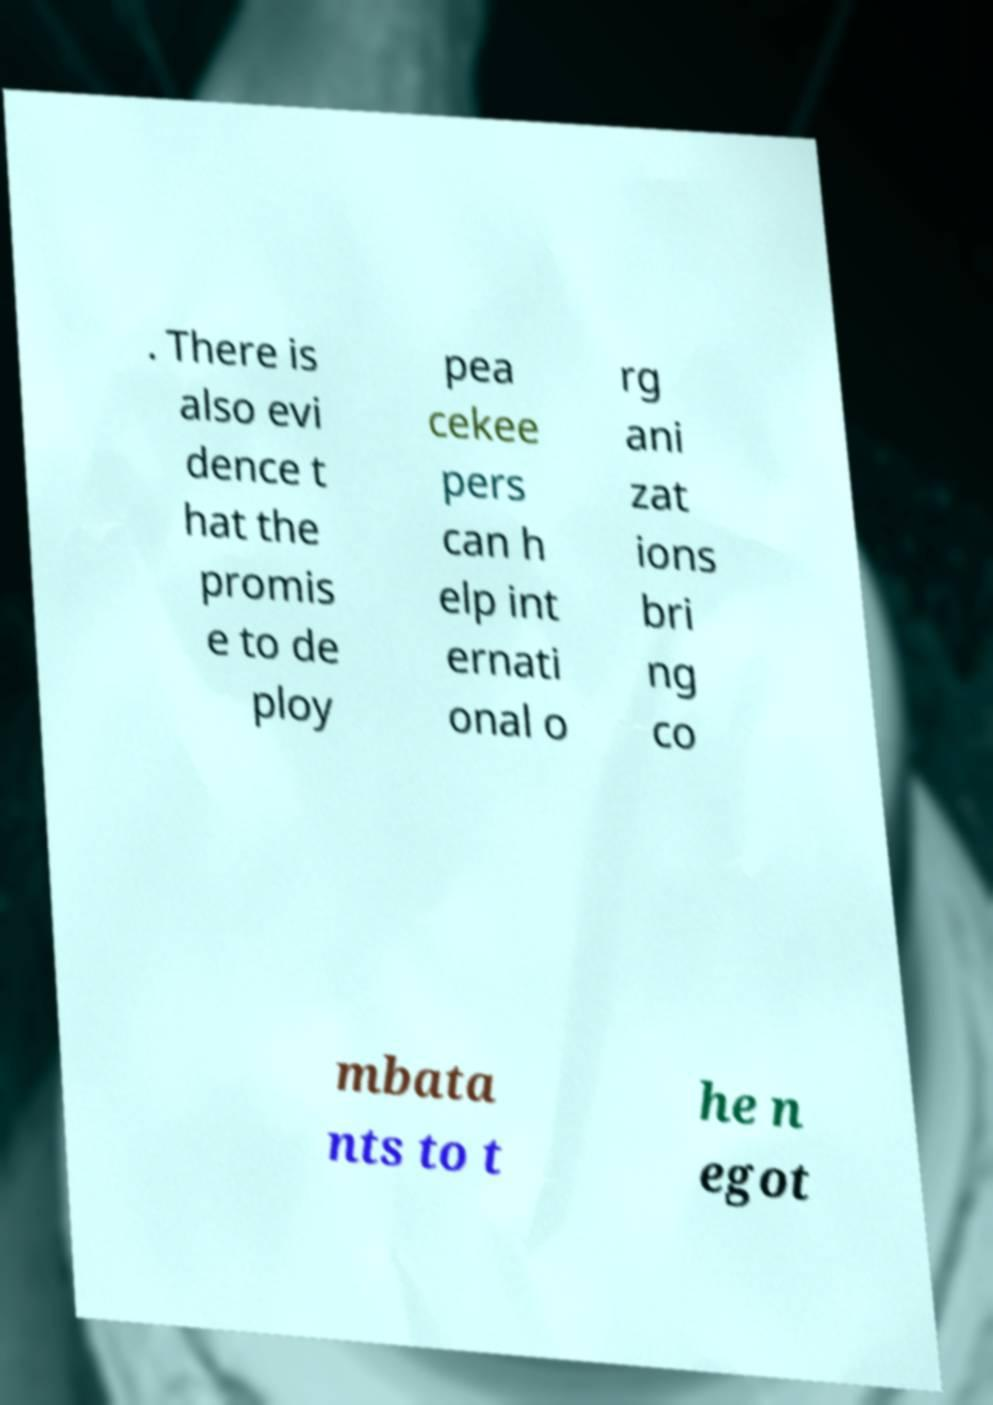Please read and relay the text visible in this image. What does it say? . There is also evi dence t hat the promis e to de ploy pea cekee pers can h elp int ernati onal o rg ani zat ions bri ng co mbata nts to t he n egot 